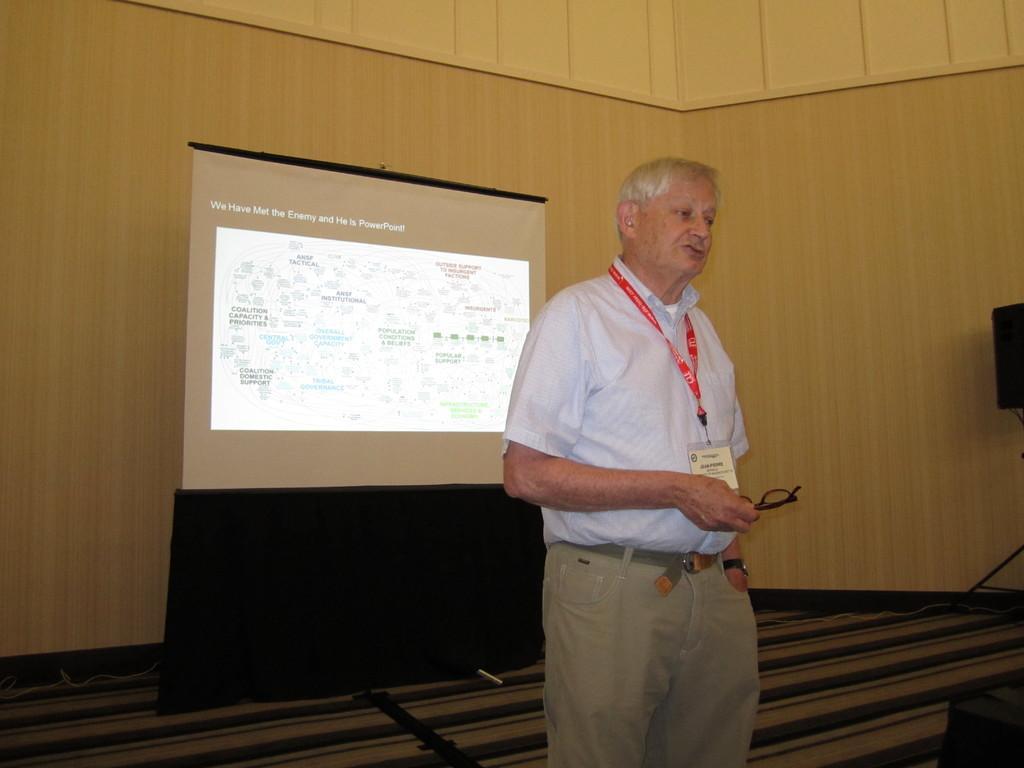Can you describe this image briefly? In this picture we can observe a person wearing a shirt and a red color tag in his neck. He is holding spectacles in his hand. Behind him we can observe a projector display screen. In the background there is a cream color wall. On the right side we can observe a speaker. 